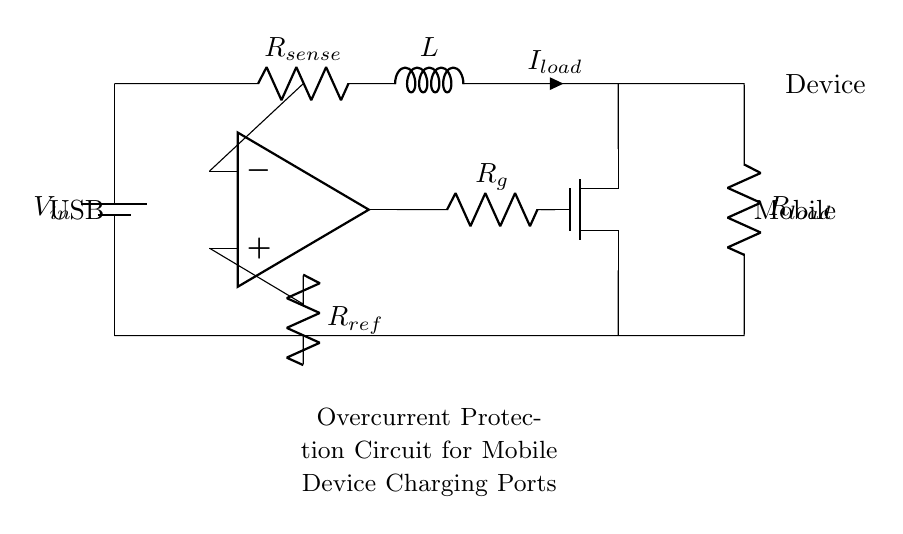What component is used to sense current? The current sensing component in the circuit is represented as R_sense, which is connected in series with the load. This resistor measures the voltage drop caused by the load current passing through it, allowing for current sensing.
Answer: R_sense What is the function of the operational amplifier? The operational amplifier in the circuit acts as a comparator, comparing the voltage drop across the sensing resistor (R_sense) and a reference voltage (R_ref). It helps determine if the load current exceeds a predetermined threshold, triggering protective actions if necessary.
Answer: Comparator What does the MOSFET control in this circuit? The MOSFET (represented as an NMOS in the diagram) is used to control the flow of current to the load. When the voltage output from the op-amp indicates an overcurrent condition, the MOSFET will turn off, preventing further current flow to protect the mobile device.
Answer: Current flow What is the purpose of the reference resistor? The reference resistor (R_ref) sets a baseline voltage level that the operational amplifier compares against the voltage from R_sense. This allows the circuit to determine whether the current is within acceptable limits or indicative of overcurrent conditions.
Answer: Baseline voltage What happens when the load current exceeds the threshold? When the load current exceeds the threshold, the operational amplifier produces a high output signal that turns off the MOSFET, thereby interrupting the power supply to the load and protecting the device from potential damage due to overcurrent.
Answer: Interrupts power supply 